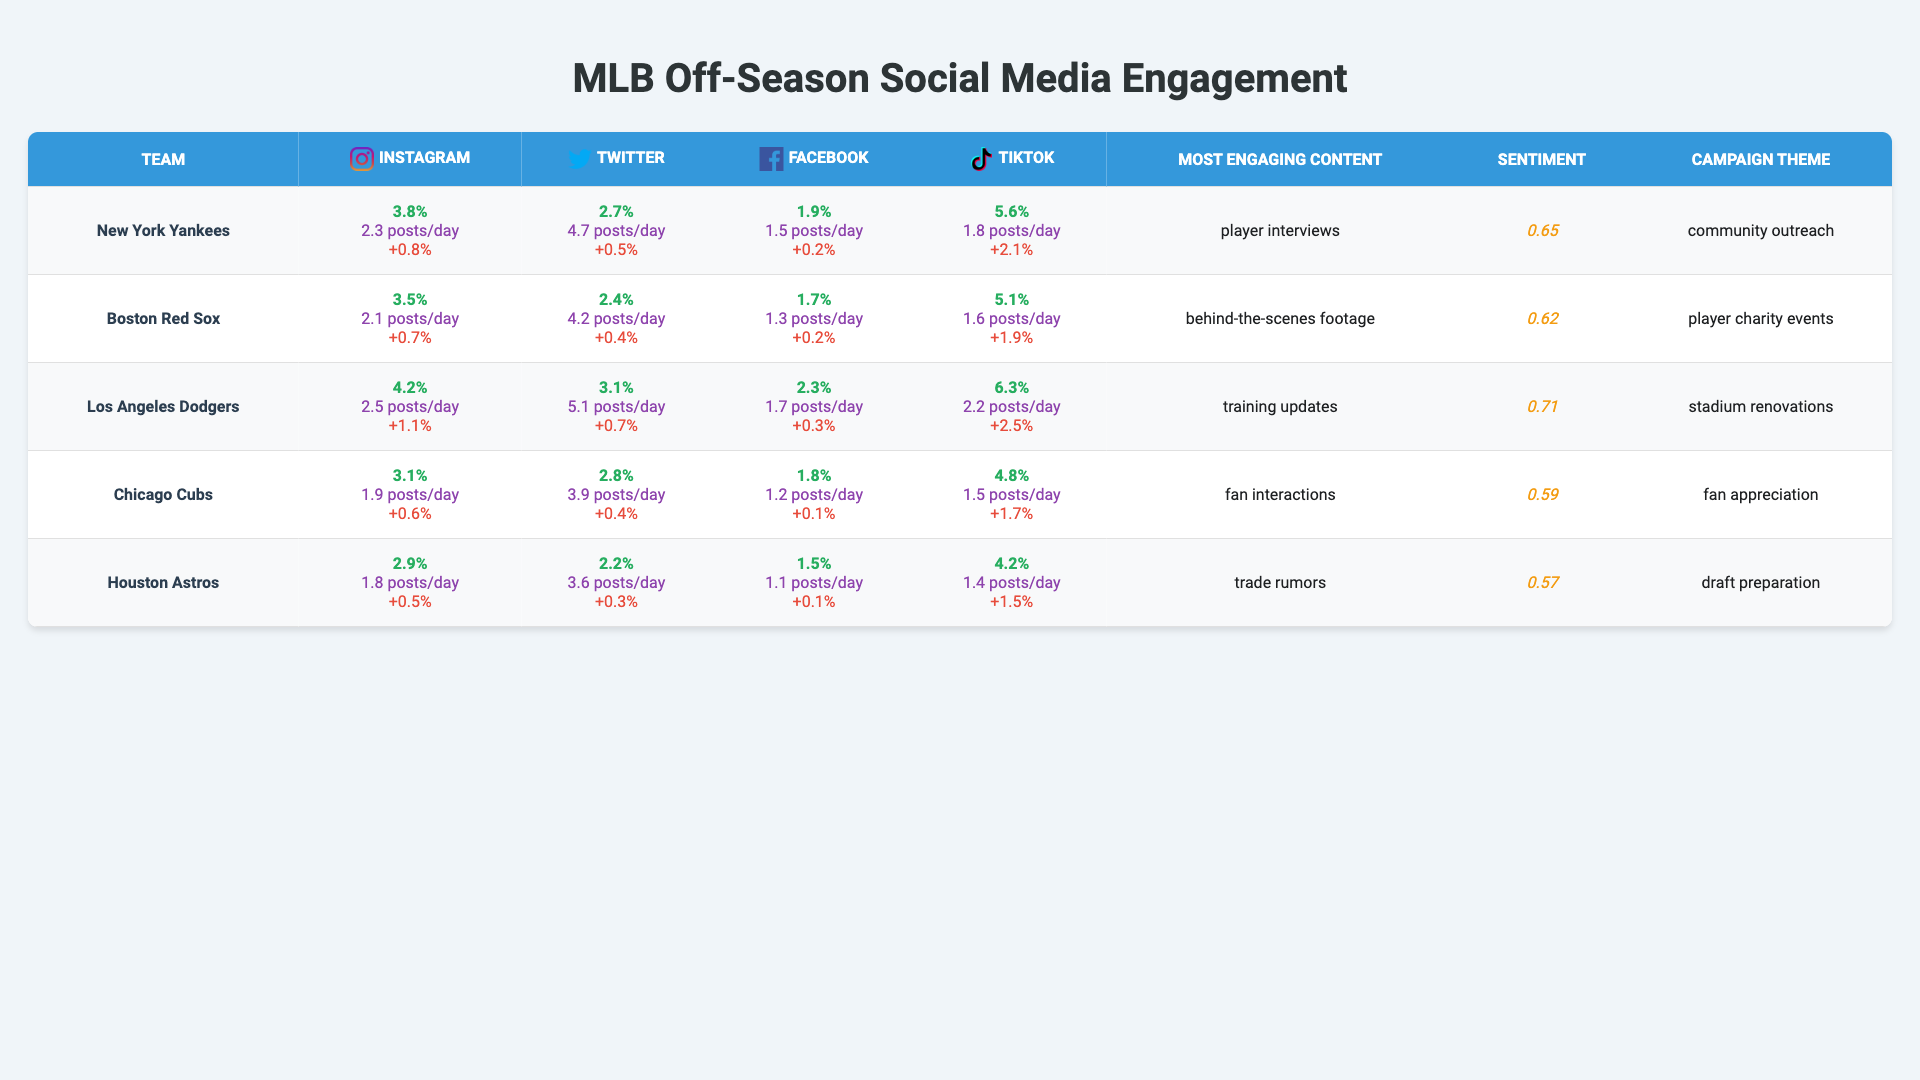What is the engagement rate for the Los Angeles Dodgers on Instagram? The table lists the engagement rates for all teams. For the Los Angeles Dodgers, the engagement rate on Instagram is 4.2%.
Answer: 4.2% Which team has the highest engagement rate on TikTok? By comparing the TikTok engagement rates of all teams listed, the Los Angeles Dodgers have the highest engagement rate at 6.3%.
Answer: Los Angeles Dodgers What is the average daily post count for the New York Yankees on Twitter? The table shows that the New York Yankees post an average of 4.7 times per day on Twitter.
Answer: 4.7 posts/day Which team has the lowest follower growth rate on Facebook? Reviewing follower growth rates in the table, we see that the Houston Astros have the lowest rate at 0.1%.
Answer: Houston Astros What is the combined average engagement rate across all teams for Twitter? First, we must sum the engagement rates on Twitter: (2.7 + 2.4 + 3.1 + 2.8 + 2.2) = 13.2. Then, divide by the number of teams, 5: 13.2 / 5 = 2.64%.
Answer: 2.64% Which team has the most engaging content type as "training updates"? The Chicago Cubs are listed as the team whose most engaging content type is "training updates."
Answer: Chicago Cubs Is it true that the Boston Red Sox have a higher engagement rate on Facebook than the Houston Astros? The engagement rate for the Boston Red Sox on Facebook is 1.7%, while for the Houston Astros, it is 1.5%. Since 1.7% is greater than 1.5%, the statement is true.
Answer: Yes Which team has the highest average comment sentiment? By looking at the average comment sentiment scores, the Los Angeles Dodgers have the highest score at 0.71.
Answer: Los Angeles Dodgers Calculate the average engagement rate for Instagram across all teams. Adding the Instagram engagement rates (3.8 + 3.5 + 4.2 + 3.1 + 2.9) gives 17.5, and dividing by the number of teams (5) provides the average: 17.5 / 5 = 3.5%.
Answer: 3.5% Has the Houston Astros used "draft preparation" as an off-season campaign theme? The table indicates that the Houston Astros' off-season campaign theme is "draft preparation," confirming that they do use it.
Answer: Yes 